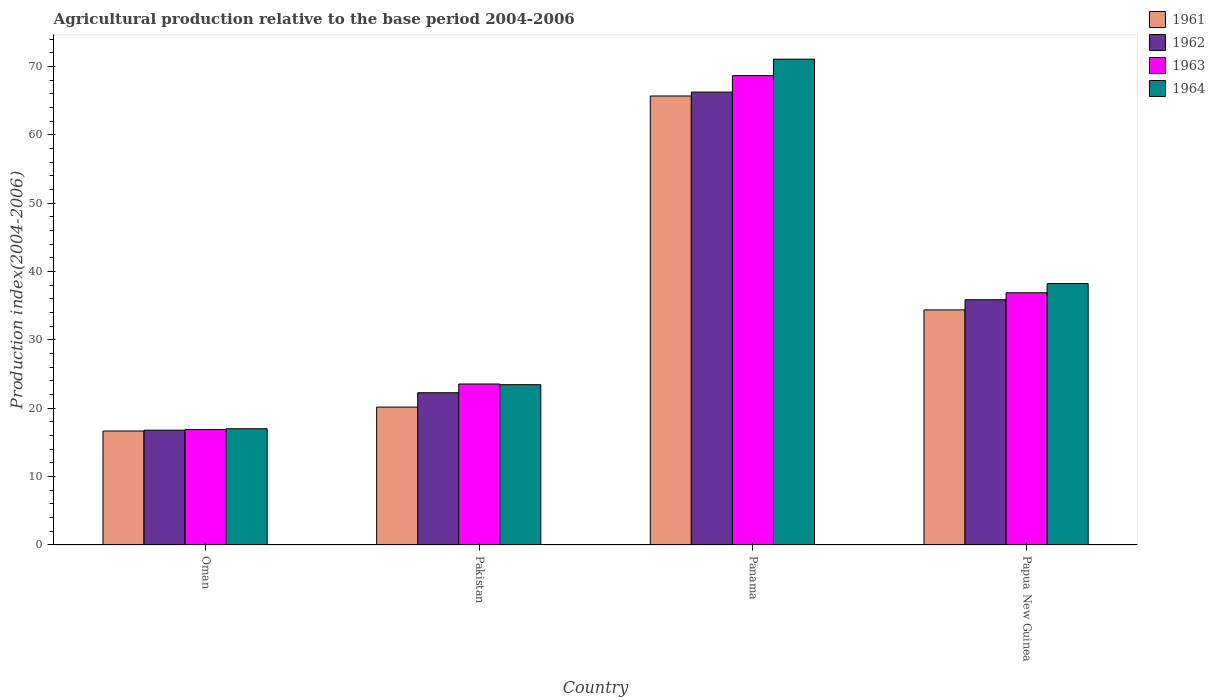How many groups of bars are there?
Your answer should be very brief. 4. How many bars are there on the 1st tick from the left?
Give a very brief answer. 4. How many bars are there on the 3rd tick from the right?
Provide a short and direct response. 4. What is the label of the 1st group of bars from the left?
Give a very brief answer. Oman. What is the agricultural production index in 1963 in Papua New Guinea?
Your answer should be very brief. 36.9. Across all countries, what is the maximum agricultural production index in 1961?
Your answer should be compact. 65.69. Across all countries, what is the minimum agricultural production index in 1961?
Your answer should be compact. 16.67. In which country was the agricultural production index in 1963 maximum?
Provide a succinct answer. Panama. In which country was the agricultural production index in 1962 minimum?
Your answer should be compact. Oman. What is the total agricultural production index in 1962 in the graph?
Offer a terse response. 141.2. What is the difference between the agricultural production index in 1961 in Oman and that in Papua New Guinea?
Ensure brevity in your answer.  -17.72. What is the difference between the agricultural production index in 1961 in Panama and the agricultural production index in 1962 in Oman?
Offer a terse response. 48.9. What is the average agricultural production index in 1964 per country?
Your answer should be very brief. 37.44. What is the difference between the agricultural production index of/in 1964 and agricultural production index of/in 1961 in Oman?
Make the answer very short. 0.33. In how many countries, is the agricultural production index in 1964 greater than 72?
Offer a very short reply. 0. What is the ratio of the agricultural production index in 1961 in Panama to that in Papua New Guinea?
Provide a short and direct response. 1.91. What is the difference between the highest and the second highest agricultural production index in 1963?
Make the answer very short. 31.77. What is the difference between the highest and the lowest agricultural production index in 1964?
Your response must be concise. 54.08. Is the sum of the agricultural production index in 1964 in Panama and Papua New Guinea greater than the maximum agricultural production index in 1962 across all countries?
Keep it short and to the point. Yes. Is it the case that in every country, the sum of the agricultural production index in 1963 and agricultural production index in 1964 is greater than the sum of agricultural production index in 1961 and agricultural production index in 1962?
Give a very brief answer. No. What does the 3rd bar from the left in Pakistan represents?
Offer a terse response. 1963. How many bars are there?
Make the answer very short. 16. Are all the bars in the graph horizontal?
Keep it short and to the point. No. Are the values on the major ticks of Y-axis written in scientific E-notation?
Provide a short and direct response. No. Does the graph contain grids?
Make the answer very short. No. Where does the legend appear in the graph?
Your response must be concise. Top right. How many legend labels are there?
Your answer should be compact. 4. What is the title of the graph?
Your answer should be compact. Agricultural production relative to the base period 2004-2006. Does "1995" appear as one of the legend labels in the graph?
Give a very brief answer. No. What is the label or title of the X-axis?
Offer a terse response. Country. What is the label or title of the Y-axis?
Offer a terse response. Production index(2004-2006). What is the Production index(2004-2006) in 1961 in Oman?
Your answer should be very brief. 16.67. What is the Production index(2004-2006) in 1962 in Oman?
Offer a very short reply. 16.79. What is the Production index(2004-2006) in 1963 in Oman?
Keep it short and to the point. 16.88. What is the Production index(2004-2006) of 1964 in Oman?
Offer a terse response. 17. What is the Production index(2004-2006) in 1961 in Pakistan?
Provide a short and direct response. 20.17. What is the Production index(2004-2006) of 1962 in Pakistan?
Your answer should be compact. 22.27. What is the Production index(2004-2006) in 1963 in Pakistan?
Your answer should be very brief. 23.55. What is the Production index(2004-2006) of 1964 in Pakistan?
Your response must be concise. 23.45. What is the Production index(2004-2006) of 1961 in Panama?
Give a very brief answer. 65.69. What is the Production index(2004-2006) of 1962 in Panama?
Your answer should be very brief. 66.26. What is the Production index(2004-2006) of 1963 in Panama?
Ensure brevity in your answer.  68.67. What is the Production index(2004-2006) of 1964 in Panama?
Keep it short and to the point. 71.08. What is the Production index(2004-2006) of 1961 in Papua New Guinea?
Your answer should be compact. 34.39. What is the Production index(2004-2006) of 1962 in Papua New Guinea?
Your answer should be very brief. 35.88. What is the Production index(2004-2006) in 1963 in Papua New Guinea?
Ensure brevity in your answer.  36.9. What is the Production index(2004-2006) in 1964 in Papua New Guinea?
Your answer should be compact. 38.24. Across all countries, what is the maximum Production index(2004-2006) of 1961?
Ensure brevity in your answer.  65.69. Across all countries, what is the maximum Production index(2004-2006) of 1962?
Your response must be concise. 66.26. Across all countries, what is the maximum Production index(2004-2006) of 1963?
Offer a terse response. 68.67. Across all countries, what is the maximum Production index(2004-2006) of 1964?
Make the answer very short. 71.08. Across all countries, what is the minimum Production index(2004-2006) in 1961?
Ensure brevity in your answer.  16.67. Across all countries, what is the minimum Production index(2004-2006) in 1962?
Keep it short and to the point. 16.79. Across all countries, what is the minimum Production index(2004-2006) in 1963?
Your response must be concise. 16.88. Across all countries, what is the minimum Production index(2004-2006) of 1964?
Your answer should be very brief. 17. What is the total Production index(2004-2006) in 1961 in the graph?
Provide a short and direct response. 136.92. What is the total Production index(2004-2006) in 1962 in the graph?
Your response must be concise. 141.2. What is the total Production index(2004-2006) of 1963 in the graph?
Make the answer very short. 146. What is the total Production index(2004-2006) of 1964 in the graph?
Your response must be concise. 149.77. What is the difference between the Production index(2004-2006) in 1961 in Oman and that in Pakistan?
Keep it short and to the point. -3.5. What is the difference between the Production index(2004-2006) of 1962 in Oman and that in Pakistan?
Give a very brief answer. -5.48. What is the difference between the Production index(2004-2006) of 1963 in Oman and that in Pakistan?
Keep it short and to the point. -6.67. What is the difference between the Production index(2004-2006) of 1964 in Oman and that in Pakistan?
Give a very brief answer. -6.45. What is the difference between the Production index(2004-2006) in 1961 in Oman and that in Panama?
Provide a short and direct response. -49.02. What is the difference between the Production index(2004-2006) of 1962 in Oman and that in Panama?
Your answer should be compact. -49.47. What is the difference between the Production index(2004-2006) in 1963 in Oman and that in Panama?
Offer a very short reply. -51.79. What is the difference between the Production index(2004-2006) in 1964 in Oman and that in Panama?
Make the answer very short. -54.08. What is the difference between the Production index(2004-2006) in 1961 in Oman and that in Papua New Guinea?
Your answer should be very brief. -17.72. What is the difference between the Production index(2004-2006) in 1962 in Oman and that in Papua New Guinea?
Offer a terse response. -19.09. What is the difference between the Production index(2004-2006) of 1963 in Oman and that in Papua New Guinea?
Your answer should be compact. -20.02. What is the difference between the Production index(2004-2006) of 1964 in Oman and that in Papua New Guinea?
Ensure brevity in your answer.  -21.24. What is the difference between the Production index(2004-2006) in 1961 in Pakistan and that in Panama?
Provide a succinct answer. -45.52. What is the difference between the Production index(2004-2006) of 1962 in Pakistan and that in Panama?
Your answer should be very brief. -43.99. What is the difference between the Production index(2004-2006) of 1963 in Pakistan and that in Panama?
Your response must be concise. -45.12. What is the difference between the Production index(2004-2006) in 1964 in Pakistan and that in Panama?
Keep it short and to the point. -47.63. What is the difference between the Production index(2004-2006) in 1961 in Pakistan and that in Papua New Guinea?
Provide a succinct answer. -14.22. What is the difference between the Production index(2004-2006) of 1962 in Pakistan and that in Papua New Guinea?
Your answer should be compact. -13.61. What is the difference between the Production index(2004-2006) in 1963 in Pakistan and that in Papua New Guinea?
Your response must be concise. -13.35. What is the difference between the Production index(2004-2006) of 1964 in Pakistan and that in Papua New Guinea?
Your response must be concise. -14.79. What is the difference between the Production index(2004-2006) of 1961 in Panama and that in Papua New Guinea?
Make the answer very short. 31.3. What is the difference between the Production index(2004-2006) in 1962 in Panama and that in Papua New Guinea?
Provide a succinct answer. 30.38. What is the difference between the Production index(2004-2006) of 1963 in Panama and that in Papua New Guinea?
Your response must be concise. 31.77. What is the difference between the Production index(2004-2006) in 1964 in Panama and that in Papua New Guinea?
Make the answer very short. 32.84. What is the difference between the Production index(2004-2006) of 1961 in Oman and the Production index(2004-2006) of 1963 in Pakistan?
Offer a very short reply. -6.88. What is the difference between the Production index(2004-2006) in 1961 in Oman and the Production index(2004-2006) in 1964 in Pakistan?
Provide a succinct answer. -6.78. What is the difference between the Production index(2004-2006) in 1962 in Oman and the Production index(2004-2006) in 1963 in Pakistan?
Keep it short and to the point. -6.76. What is the difference between the Production index(2004-2006) in 1962 in Oman and the Production index(2004-2006) in 1964 in Pakistan?
Your response must be concise. -6.66. What is the difference between the Production index(2004-2006) in 1963 in Oman and the Production index(2004-2006) in 1964 in Pakistan?
Provide a short and direct response. -6.57. What is the difference between the Production index(2004-2006) of 1961 in Oman and the Production index(2004-2006) of 1962 in Panama?
Give a very brief answer. -49.59. What is the difference between the Production index(2004-2006) of 1961 in Oman and the Production index(2004-2006) of 1963 in Panama?
Offer a terse response. -52. What is the difference between the Production index(2004-2006) of 1961 in Oman and the Production index(2004-2006) of 1964 in Panama?
Ensure brevity in your answer.  -54.41. What is the difference between the Production index(2004-2006) of 1962 in Oman and the Production index(2004-2006) of 1963 in Panama?
Ensure brevity in your answer.  -51.88. What is the difference between the Production index(2004-2006) of 1962 in Oman and the Production index(2004-2006) of 1964 in Panama?
Provide a succinct answer. -54.29. What is the difference between the Production index(2004-2006) in 1963 in Oman and the Production index(2004-2006) in 1964 in Panama?
Offer a terse response. -54.2. What is the difference between the Production index(2004-2006) of 1961 in Oman and the Production index(2004-2006) of 1962 in Papua New Guinea?
Ensure brevity in your answer.  -19.21. What is the difference between the Production index(2004-2006) of 1961 in Oman and the Production index(2004-2006) of 1963 in Papua New Guinea?
Keep it short and to the point. -20.23. What is the difference between the Production index(2004-2006) of 1961 in Oman and the Production index(2004-2006) of 1964 in Papua New Guinea?
Offer a very short reply. -21.57. What is the difference between the Production index(2004-2006) of 1962 in Oman and the Production index(2004-2006) of 1963 in Papua New Guinea?
Ensure brevity in your answer.  -20.11. What is the difference between the Production index(2004-2006) of 1962 in Oman and the Production index(2004-2006) of 1964 in Papua New Guinea?
Provide a succinct answer. -21.45. What is the difference between the Production index(2004-2006) of 1963 in Oman and the Production index(2004-2006) of 1964 in Papua New Guinea?
Make the answer very short. -21.36. What is the difference between the Production index(2004-2006) of 1961 in Pakistan and the Production index(2004-2006) of 1962 in Panama?
Make the answer very short. -46.09. What is the difference between the Production index(2004-2006) in 1961 in Pakistan and the Production index(2004-2006) in 1963 in Panama?
Keep it short and to the point. -48.5. What is the difference between the Production index(2004-2006) in 1961 in Pakistan and the Production index(2004-2006) in 1964 in Panama?
Ensure brevity in your answer.  -50.91. What is the difference between the Production index(2004-2006) in 1962 in Pakistan and the Production index(2004-2006) in 1963 in Panama?
Your answer should be very brief. -46.4. What is the difference between the Production index(2004-2006) in 1962 in Pakistan and the Production index(2004-2006) in 1964 in Panama?
Provide a succinct answer. -48.81. What is the difference between the Production index(2004-2006) in 1963 in Pakistan and the Production index(2004-2006) in 1964 in Panama?
Offer a terse response. -47.53. What is the difference between the Production index(2004-2006) in 1961 in Pakistan and the Production index(2004-2006) in 1962 in Papua New Guinea?
Offer a terse response. -15.71. What is the difference between the Production index(2004-2006) in 1961 in Pakistan and the Production index(2004-2006) in 1963 in Papua New Guinea?
Keep it short and to the point. -16.73. What is the difference between the Production index(2004-2006) in 1961 in Pakistan and the Production index(2004-2006) in 1964 in Papua New Guinea?
Provide a succinct answer. -18.07. What is the difference between the Production index(2004-2006) in 1962 in Pakistan and the Production index(2004-2006) in 1963 in Papua New Guinea?
Provide a short and direct response. -14.63. What is the difference between the Production index(2004-2006) of 1962 in Pakistan and the Production index(2004-2006) of 1964 in Papua New Guinea?
Keep it short and to the point. -15.97. What is the difference between the Production index(2004-2006) in 1963 in Pakistan and the Production index(2004-2006) in 1964 in Papua New Guinea?
Your answer should be compact. -14.69. What is the difference between the Production index(2004-2006) in 1961 in Panama and the Production index(2004-2006) in 1962 in Papua New Guinea?
Your response must be concise. 29.81. What is the difference between the Production index(2004-2006) of 1961 in Panama and the Production index(2004-2006) of 1963 in Papua New Guinea?
Your answer should be very brief. 28.79. What is the difference between the Production index(2004-2006) of 1961 in Panama and the Production index(2004-2006) of 1964 in Papua New Guinea?
Your response must be concise. 27.45. What is the difference between the Production index(2004-2006) in 1962 in Panama and the Production index(2004-2006) in 1963 in Papua New Guinea?
Make the answer very short. 29.36. What is the difference between the Production index(2004-2006) in 1962 in Panama and the Production index(2004-2006) in 1964 in Papua New Guinea?
Your answer should be compact. 28.02. What is the difference between the Production index(2004-2006) of 1963 in Panama and the Production index(2004-2006) of 1964 in Papua New Guinea?
Your answer should be compact. 30.43. What is the average Production index(2004-2006) in 1961 per country?
Make the answer very short. 34.23. What is the average Production index(2004-2006) of 1962 per country?
Provide a short and direct response. 35.3. What is the average Production index(2004-2006) of 1963 per country?
Offer a terse response. 36.5. What is the average Production index(2004-2006) of 1964 per country?
Provide a short and direct response. 37.44. What is the difference between the Production index(2004-2006) of 1961 and Production index(2004-2006) of 1962 in Oman?
Offer a very short reply. -0.12. What is the difference between the Production index(2004-2006) of 1961 and Production index(2004-2006) of 1963 in Oman?
Provide a short and direct response. -0.21. What is the difference between the Production index(2004-2006) in 1961 and Production index(2004-2006) in 1964 in Oman?
Your response must be concise. -0.33. What is the difference between the Production index(2004-2006) in 1962 and Production index(2004-2006) in 1963 in Oman?
Provide a short and direct response. -0.09. What is the difference between the Production index(2004-2006) in 1962 and Production index(2004-2006) in 1964 in Oman?
Offer a terse response. -0.21. What is the difference between the Production index(2004-2006) of 1963 and Production index(2004-2006) of 1964 in Oman?
Give a very brief answer. -0.12. What is the difference between the Production index(2004-2006) of 1961 and Production index(2004-2006) of 1963 in Pakistan?
Your answer should be very brief. -3.38. What is the difference between the Production index(2004-2006) of 1961 and Production index(2004-2006) of 1964 in Pakistan?
Offer a very short reply. -3.28. What is the difference between the Production index(2004-2006) in 1962 and Production index(2004-2006) in 1963 in Pakistan?
Your response must be concise. -1.28. What is the difference between the Production index(2004-2006) in 1962 and Production index(2004-2006) in 1964 in Pakistan?
Your response must be concise. -1.18. What is the difference between the Production index(2004-2006) of 1961 and Production index(2004-2006) of 1962 in Panama?
Your response must be concise. -0.57. What is the difference between the Production index(2004-2006) in 1961 and Production index(2004-2006) in 1963 in Panama?
Provide a succinct answer. -2.98. What is the difference between the Production index(2004-2006) of 1961 and Production index(2004-2006) of 1964 in Panama?
Provide a succinct answer. -5.39. What is the difference between the Production index(2004-2006) of 1962 and Production index(2004-2006) of 1963 in Panama?
Keep it short and to the point. -2.41. What is the difference between the Production index(2004-2006) of 1962 and Production index(2004-2006) of 1964 in Panama?
Provide a succinct answer. -4.82. What is the difference between the Production index(2004-2006) in 1963 and Production index(2004-2006) in 1964 in Panama?
Your response must be concise. -2.41. What is the difference between the Production index(2004-2006) of 1961 and Production index(2004-2006) of 1962 in Papua New Guinea?
Offer a very short reply. -1.49. What is the difference between the Production index(2004-2006) in 1961 and Production index(2004-2006) in 1963 in Papua New Guinea?
Your response must be concise. -2.51. What is the difference between the Production index(2004-2006) in 1961 and Production index(2004-2006) in 1964 in Papua New Guinea?
Provide a short and direct response. -3.85. What is the difference between the Production index(2004-2006) of 1962 and Production index(2004-2006) of 1963 in Papua New Guinea?
Offer a terse response. -1.02. What is the difference between the Production index(2004-2006) in 1962 and Production index(2004-2006) in 1964 in Papua New Guinea?
Offer a terse response. -2.36. What is the difference between the Production index(2004-2006) in 1963 and Production index(2004-2006) in 1964 in Papua New Guinea?
Make the answer very short. -1.34. What is the ratio of the Production index(2004-2006) in 1961 in Oman to that in Pakistan?
Your answer should be very brief. 0.83. What is the ratio of the Production index(2004-2006) in 1962 in Oman to that in Pakistan?
Make the answer very short. 0.75. What is the ratio of the Production index(2004-2006) in 1963 in Oman to that in Pakistan?
Give a very brief answer. 0.72. What is the ratio of the Production index(2004-2006) of 1964 in Oman to that in Pakistan?
Your answer should be very brief. 0.72. What is the ratio of the Production index(2004-2006) of 1961 in Oman to that in Panama?
Ensure brevity in your answer.  0.25. What is the ratio of the Production index(2004-2006) in 1962 in Oman to that in Panama?
Make the answer very short. 0.25. What is the ratio of the Production index(2004-2006) in 1963 in Oman to that in Panama?
Offer a terse response. 0.25. What is the ratio of the Production index(2004-2006) of 1964 in Oman to that in Panama?
Your answer should be very brief. 0.24. What is the ratio of the Production index(2004-2006) of 1961 in Oman to that in Papua New Guinea?
Make the answer very short. 0.48. What is the ratio of the Production index(2004-2006) of 1962 in Oman to that in Papua New Guinea?
Your answer should be compact. 0.47. What is the ratio of the Production index(2004-2006) in 1963 in Oman to that in Papua New Guinea?
Give a very brief answer. 0.46. What is the ratio of the Production index(2004-2006) in 1964 in Oman to that in Papua New Guinea?
Your answer should be compact. 0.44. What is the ratio of the Production index(2004-2006) of 1961 in Pakistan to that in Panama?
Make the answer very short. 0.31. What is the ratio of the Production index(2004-2006) of 1962 in Pakistan to that in Panama?
Offer a terse response. 0.34. What is the ratio of the Production index(2004-2006) of 1963 in Pakistan to that in Panama?
Your response must be concise. 0.34. What is the ratio of the Production index(2004-2006) of 1964 in Pakistan to that in Panama?
Offer a terse response. 0.33. What is the ratio of the Production index(2004-2006) of 1961 in Pakistan to that in Papua New Guinea?
Provide a succinct answer. 0.59. What is the ratio of the Production index(2004-2006) in 1962 in Pakistan to that in Papua New Guinea?
Ensure brevity in your answer.  0.62. What is the ratio of the Production index(2004-2006) of 1963 in Pakistan to that in Papua New Guinea?
Offer a very short reply. 0.64. What is the ratio of the Production index(2004-2006) of 1964 in Pakistan to that in Papua New Guinea?
Provide a short and direct response. 0.61. What is the ratio of the Production index(2004-2006) of 1961 in Panama to that in Papua New Guinea?
Provide a short and direct response. 1.91. What is the ratio of the Production index(2004-2006) of 1962 in Panama to that in Papua New Guinea?
Offer a very short reply. 1.85. What is the ratio of the Production index(2004-2006) of 1963 in Panama to that in Papua New Guinea?
Provide a succinct answer. 1.86. What is the ratio of the Production index(2004-2006) in 1964 in Panama to that in Papua New Guinea?
Make the answer very short. 1.86. What is the difference between the highest and the second highest Production index(2004-2006) of 1961?
Your answer should be compact. 31.3. What is the difference between the highest and the second highest Production index(2004-2006) in 1962?
Keep it short and to the point. 30.38. What is the difference between the highest and the second highest Production index(2004-2006) of 1963?
Ensure brevity in your answer.  31.77. What is the difference between the highest and the second highest Production index(2004-2006) of 1964?
Ensure brevity in your answer.  32.84. What is the difference between the highest and the lowest Production index(2004-2006) of 1961?
Ensure brevity in your answer.  49.02. What is the difference between the highest and the lowest Production index(2004-2006) of 1962?
Make the answer very short. 49.47. What is the difference between the highest and the lowest Production index(2004-2006) of 1963?
Your response must be concise. 51.79. What is the difference between the highest and the lowest Production index(2004-2006) in 1964?
Keep it short and to the point. 54.08. 